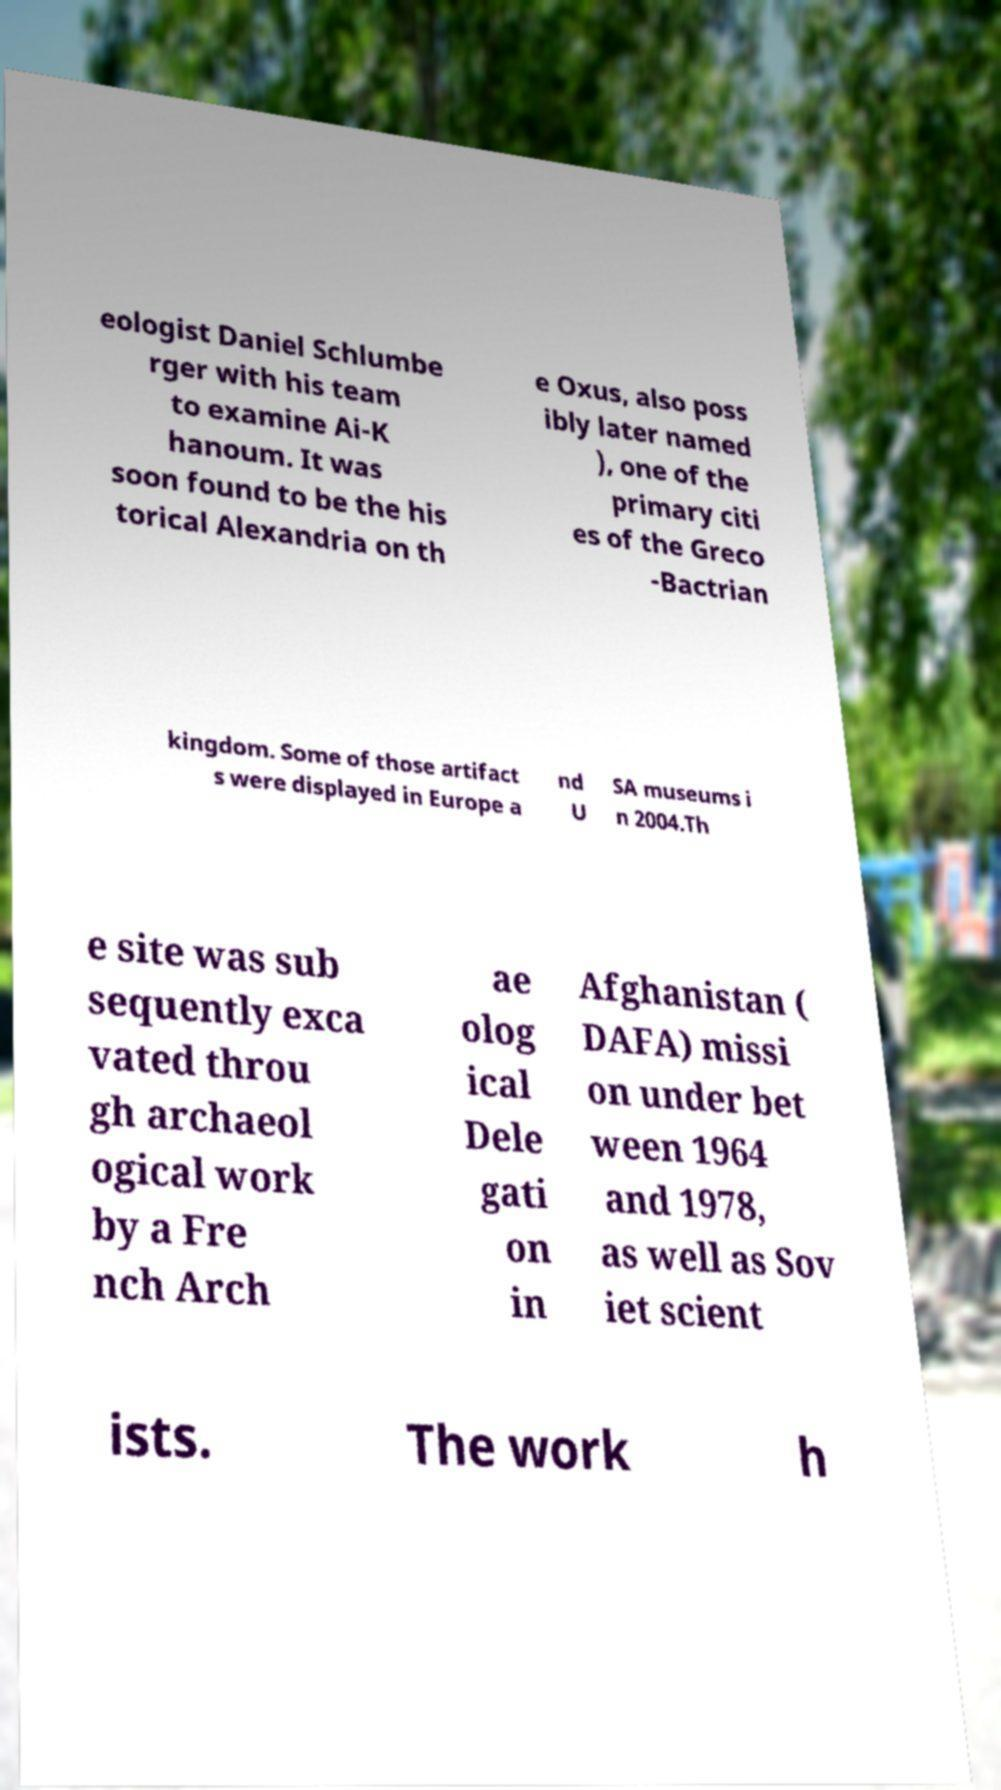I need the written content from this picture converted into text. Can you do that? eologist Daniel Schlumbe rger with his team to examine Ai-K hanoum. It was soon found to be the his torical Alexandria on th e Oxus, also poss ibly later named ), one of the primary citi es of the Greco -Bactrian kingdom. Some of those artifact s were displayed in Europe a nd U SA museums i n 2004.Th e site was sub sequently exca vated throu gh archaeol ogical work by a Fre nch Arch ae olog ical Dele gati on in Afghanistan ( DAFA) missi on under bet ween 1964 and 1978, as well as Sov iet scient ists. The work h 